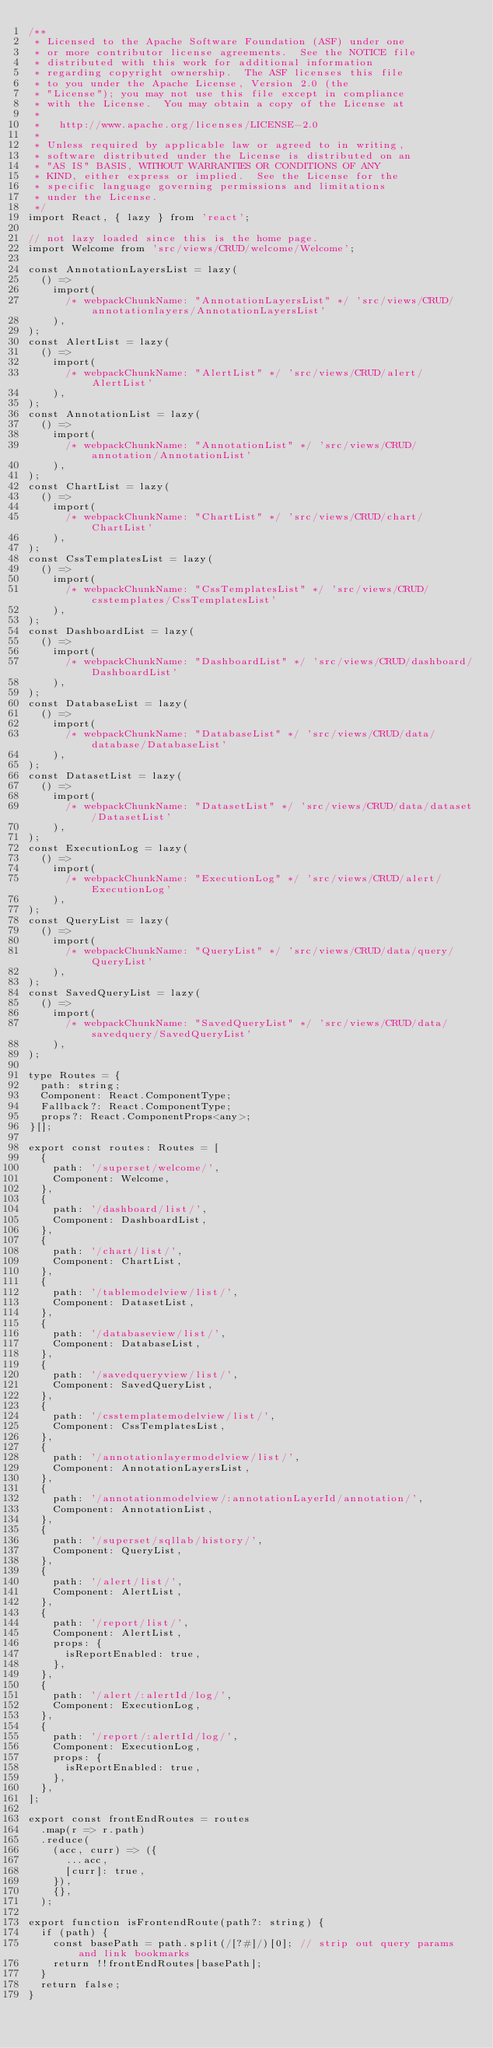<code> <loc_0><loc_0><loc_500><loc_500><_TypeScript_>/**
 * Licensed to the Apache Software Foundation (ASF) under one
 * or more contributor license agreements.  See the NOTICE file
 * distributed with this work for additional information
 * regarding copyright ownership.  The ASF licenses this file
 * to you under the Apache License, Version 2.0 (the
 * "License"); you may not use this file except in compliance
 * with the License.  You may obtain a copy of the License at
 *
 *   http://www.apache.org/licenses/LICENSE-2.0
 *
 * Unless required by applicable law or agreed to in writing,
 * software distributed under the License is distributed on an
 * "AS IS" BASIS, WITHOUT WARRANTIES OR CONDITIONS OF ANY
 * KIND, either express or implied.  See the License for the
 * specific language governing permissions and limitations
 * under the License.
 */
import React, { lazy } from 'react';

// not lazy loaded since this is the home page.
import Welcome from 'src/views/CRUD/welcome/Welcome';

const AnnotationLayersList = lazy(
  () =>
    import(
      /* webpackChunkName: "AnnotationLayersList" */ 'src/views/CRUD/annotationlayers/AnnotationLayersList'
    ),
);
const AlertList = lazy(
  () =>
    import(
      /* webpackChunkName: "AlertList" */ 'src/views/CRUD/alert/AlertList'
    ),
);
const AnnotationList = lazy(
  () =>
    import(
      /* webpackChunkName: "AnnotationList" */ 'src/views/CRUD/annotation/AnnotationList'
    ),
);
const ChartList = lazy(
  () =>
    import(
      /* webpackChunkName: "ChartList" */ 'src/views/CRUD/chart/ChartList'
    ),
);
const CssTemplatesList = lazy(
  () =>
    import(
      /* webpackChunkName: "CssTemplatesList" */ 'src/views/CRUD/csstemplates/CssTemplatesList'
    ),
);
const DashboardList = lazy(
  () =>
    import(
      /* webpackChunkName: "DashboardList" */ 'src/views/CRUD/dashboard/DashboardList'
    ),
);
const DatabaseList = lazy(
  () =>
    import(
      /* webpackChunkName: "DatabaseList" */ 'src/views/CRUD/data/database/DatabaseList'
    ),
);
const DatasetList = lazy(
  () =>
    import(
      /* webpackChunkName: "DatasetList" */ 'src/views/CRUD/data/dataset/DatasetList'
    ),
);
const ExecutionLog = lazy(
  () =>
    import(
      /* webpackChunkName: "ExecutionLog" */ 'src/views/CRUD/alert/ExecutionLog'
    ),
);
const QueryList = lazy(
  () =>
    import(
      /* webpackChunkName: "QueryList" */ 'src/views/CRUD/data/query/QueryList'
    ),
);
const SavedQueryList = lazy(
  () =>
    import(
      /* webpackChunkName: "SavedQueryList" */ 'src/views/CRUD/data/savedquery/SavedQueryList'
    ),
);

type Routes = {
  path: string;
  Component: React.ComponentType;
  Fallback?: React.ComponentType;
  props?: React.ComponentProps<any>;
}[];

export const routes: Routes = [
  {
    path: '/superset/welcome/',
    Component: Welcome,
  },
  {
    path: '/dashboard/list/',
    Component: DashboardList,
  },
  {
    path: '/chart/list/',
    Component: ChartList,
  },
  {
    path: '/tablemodelview/list/',
    Component: DatasetList,
  },
  {
    path: '/databaseview/list/',
    Component: DatabaseList,
  },
  {
    path: '/savedqueryview/list/',
    Component: SavedQueryList,
  },
  {
    path: '/csstemplatemodelview/list/',
    Component: CssTemplatesList,
  },
  {
    path: '/annotationlayermodelview/list/',
    Component: AnnotationLayersList,
  },
  {
    path: '/annotationmodelview/:annotationLayerId/annotation/',
    Component: AnnotationList,
  },
  {
    path: '/superset/sqllab/history/',
    Component: QueryList,
  },
  {
    path: '/alert/list/',
    Component: AlertList,
  },
  {
    path: '/report/list/',
    Component: AlertList,
    props: {
      isReportEnabled: true,
    },
  },
  {
    path: '/alert/:alertId/log/',
    Component: ExecutionLog,
  },
  {
    path: '/report/:alertId/log/',
    Component: ExecutionLog,
    props: {
      isReportEnabled: true,
    },
  },
];

export const frontEndRoutes = routes
  .map(r => r.path)
  .reduce(
    (acc, curr) => ({
      ...acc,
      [curr]: true,
    }),
    {},
  );

export function isFrontendRoute(path?: string) {
  if (path) {
    const basePath = path.split(/[?#]/)[0]; // strip out query params and link bookmarks
    return !!frontEndRoutes[basePath];
  }
  return false;
}
</code> 